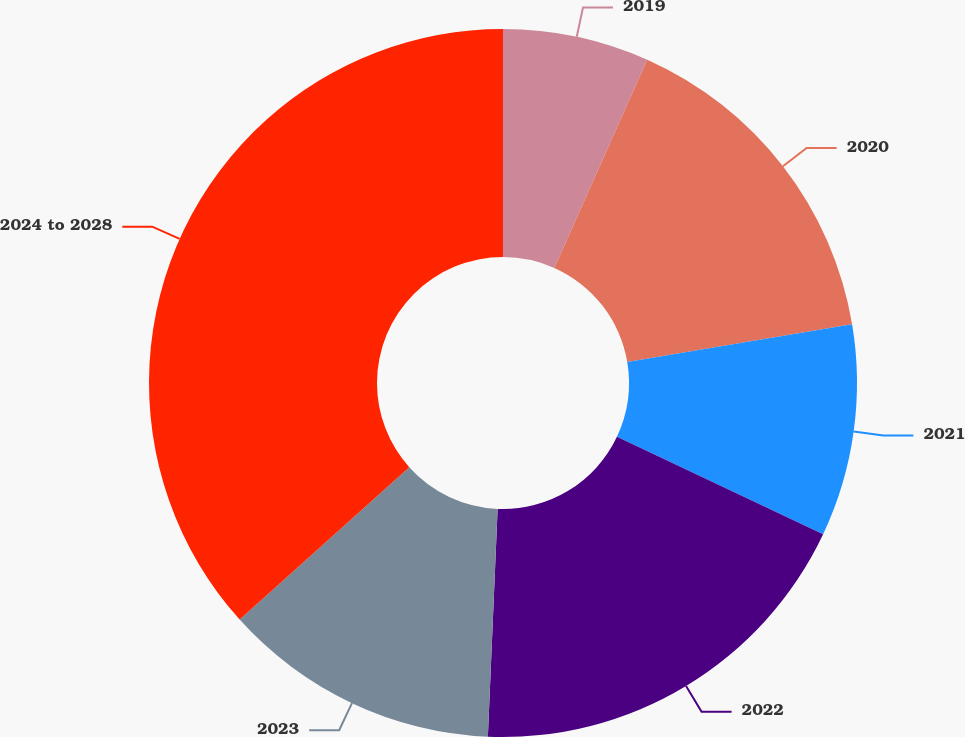Convert chart. <chart><loc_0><loc_0><loc_500><loc_500><pie_chart><fcel>2019<fcel>2020<fcel>2021<fcel>2022<fcel>2023<fcel>2024 to 2028<nl><fcel>6.68%<fcel>15.67%<fcel>9.67%<fcel>18.66%<fcel>12.67%<fcel>36.65%<nl></chart> 